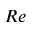Convert formula to latex. <formula><loc_0><loc_0><loc_500><loc_500>R e</formula> 